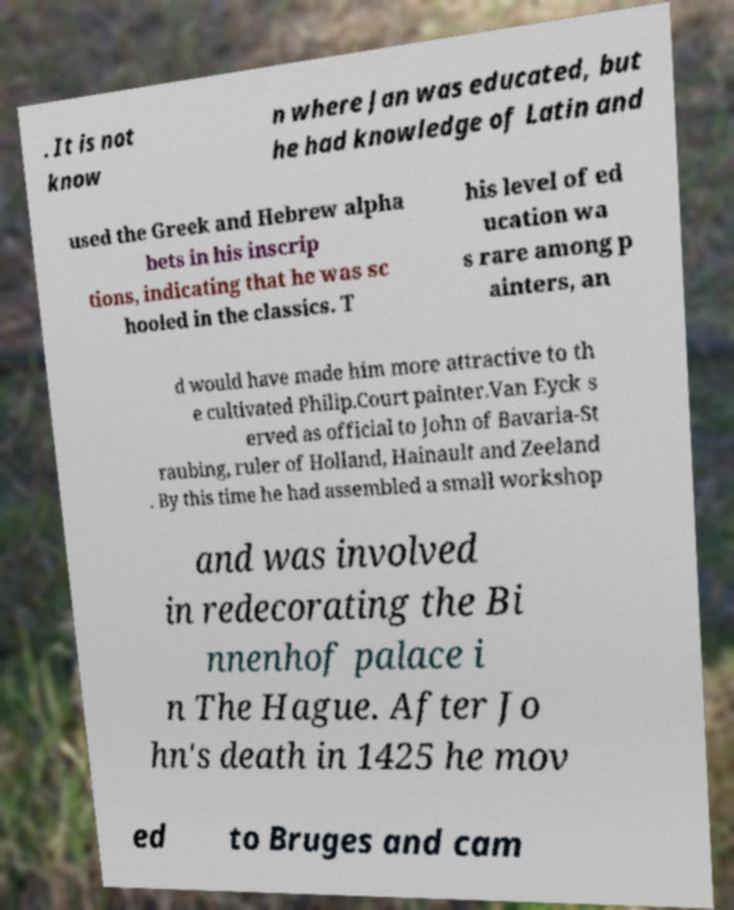Could you extract and type out the text from this image? . It is not know n where Jan was educated, but he had knowledge of Latin and used the Greek and Hebrew alpha bets in his inscrip tions, indicating that he was sc hooled in the classics. T his level of ed ucation wa s rare among p ainters, an d would have made him more attractive to th e cultivated Philip.Court painter.Van Eyck s erved as official to John of Bavaria-St raubing, ruler of Holland, Hainault and Zeeland . By this time he had assembled a small workshop and was involved in redecorating the Bi nnenhof palace i n The Hague. After Jo hn's death in 1425 he mov ed to Bruges and cam 